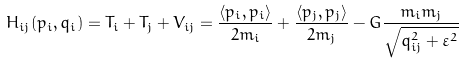Convert formula to latex. <formula><loc_0><loc_0><loc_500><loc_500>H _ { i j } ( p _ { i } , q _ { i } ) = T _ { i } + T _ { j } + V _ { i j } = { \frac { \langle p _ { i } , p _ { i } \rangle } { 2 m _ { i } } } + { \frac { \langle p _ { j } , p _ { j } \rangle } { 2 m _ { j } } } - G \frac { m _ { i } m _ { j } } { \sqrt { q _ { i j } ^ { 2 } + \varepsilon ^ { 2 } } }</formula> 